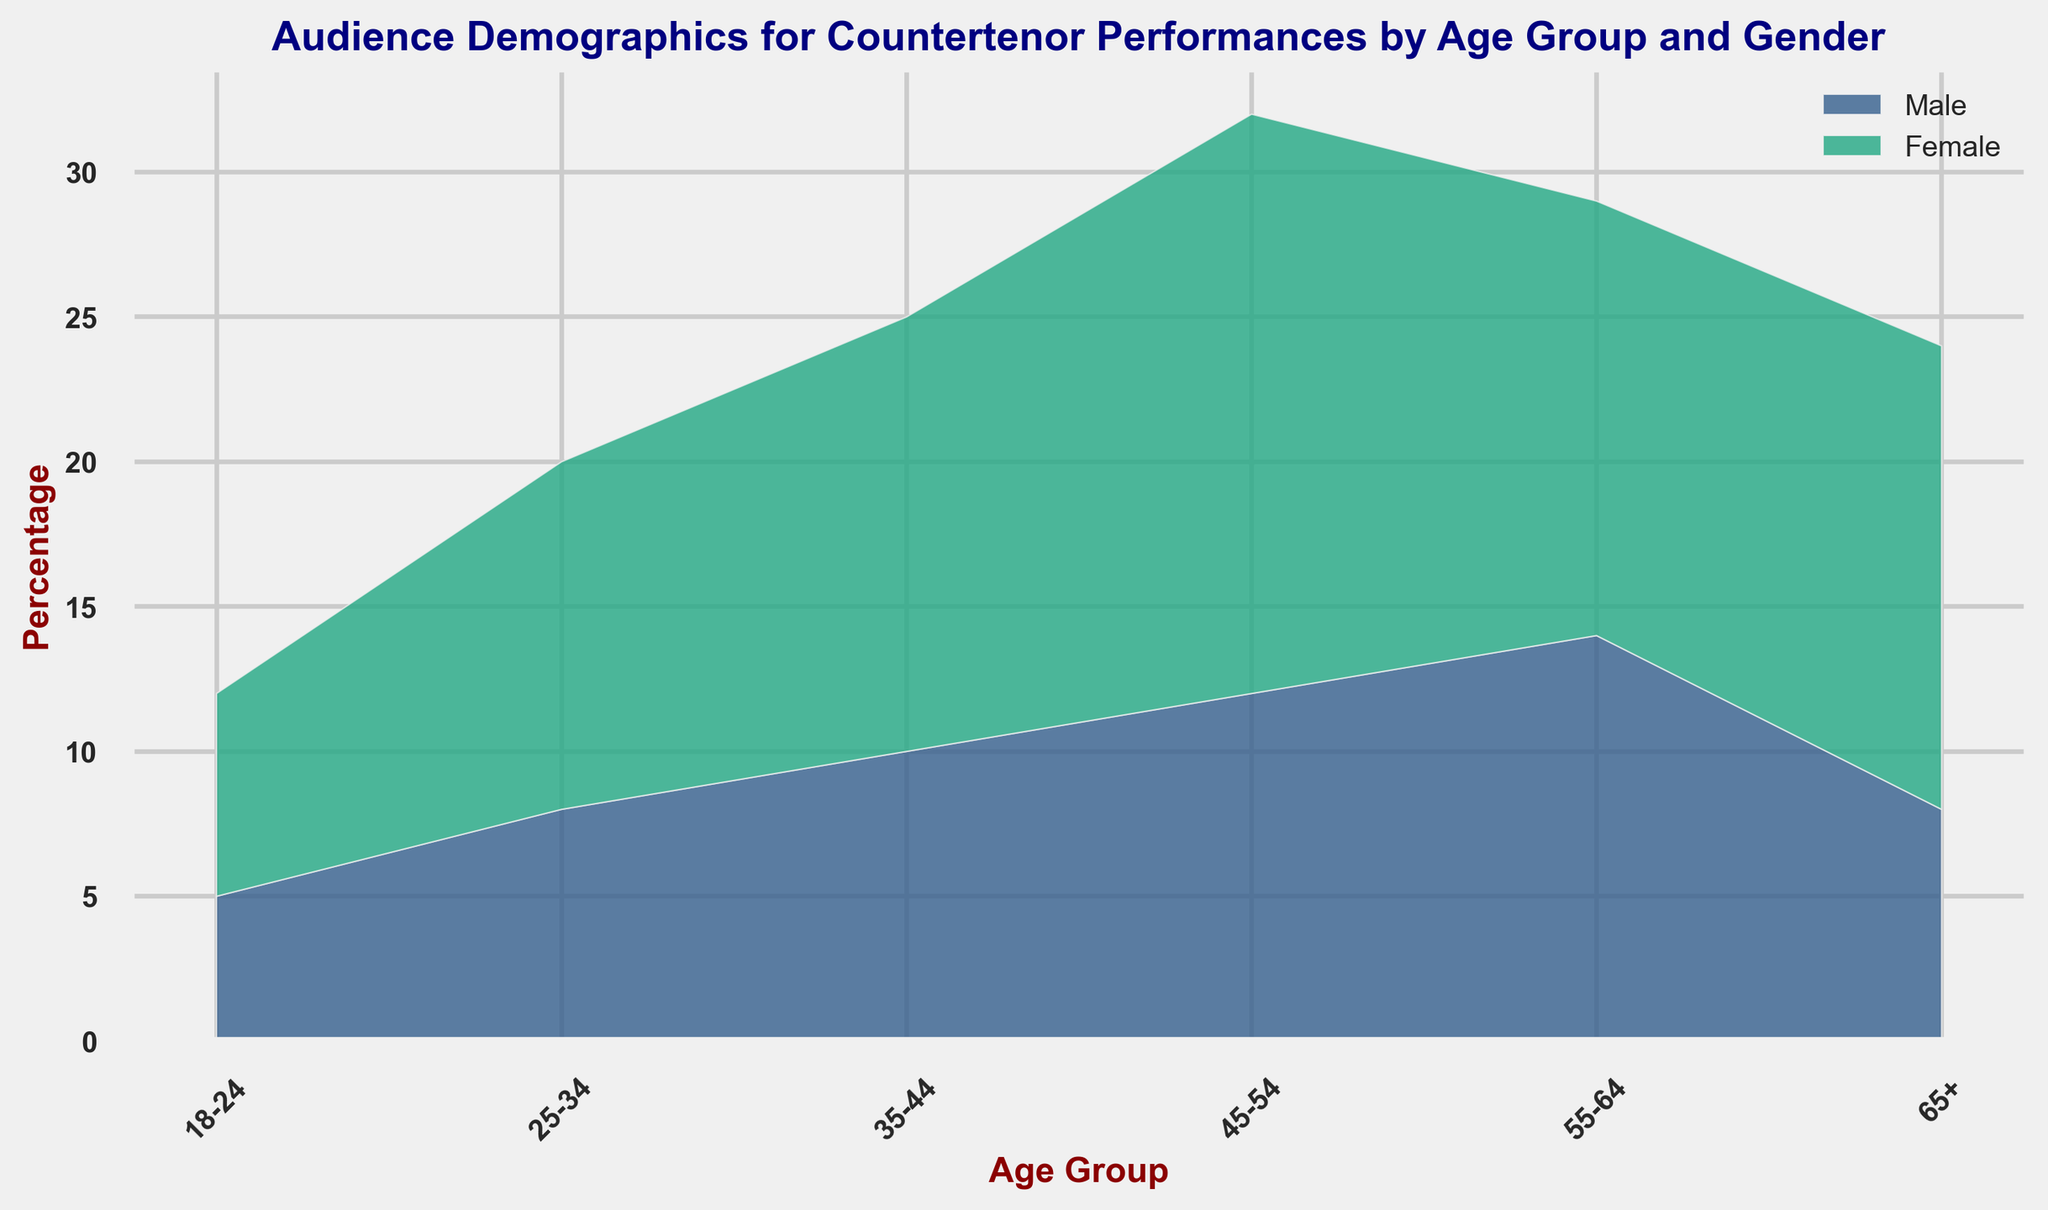What is the total percentage of female audiences across all age groups? First, identify the percentage values for females in each age group: 7 (18-24), 12 (25-34), 15 (35-44), 20 (45-54), 15 (55-64), and 16 (65+). Sum these values: 7 + 12 + 15 + 20 + 15 + 16 = 85
Answer: 85 Which age group has the highest percentage of male audiences? Identify the male percentages for each age group: 5 (18-24), 8 (25-34), 10 (35-44), 12 (45-54), 14 (55-64), and 8 (65+). The highest value is 14 in the 55-64 age group
Answer: 55-64 How does the percentage of female audiences in the 45-54 age group compare to the male audiences in the same age group? The percentage for females in the 45-54 age group is 20, and for males is 12. Compare these two values: 20 is greater than 12
Answer: Female percentage is higher What is the difference in the total percentage of audiences between the youngest (18-24) and oldest (65+) age groups? Calculate total percentages for each age group: 18-24 years (5 + 7 = 12), and 65+ years (8 + 16 = 24). The difference is 24 - 12
Answer: 12 Among the 35-44 age group, which gender has a higher audience percentage and by how much? The percentage for males is 10, and for females is 15. Calculate the difference: 15 - 10 = 5
Answer: Female by 5 What is the average percentage of audiences in the 25-34 age group? Add male (8) and female (12) percentages, then divide by 2: (8 + 12) / 2 = 10
Answer: 10 Which age group has the smallest total audience percentage, and what is that percentage? Calculate the total for each age group: 18-24 (5+7=12), 25-34 (8+12=20), 35-44 (10+15=25), 45-54 (12+20=32), 55-64 (14+15=29), 65+ (8+16=24). The smallest is 12 in the 18-24 age group
Answer: 18-24 with 12 In the 55-64 age group, do males or females have a greater audience percentage, and by what factor? Percentages are 14 for males and 15 for females. The factor by which females exceed males is 15 / 14 ≈ 1.07
Answer: Females by about 1.07 Which gender has a higher total percentage across all age groups? Calculate the total for males: 5+8+10+12+14+8=57, and for females: 7+12+15+20+15+16=85. Compare these totals
Answer: Females Is the audience more balanced in terms of gender for the 18-24 age group or the 35-44 age group? Compare the male to female percentages for each age group: 18-24 (5 males vs 7 females), 35-44 (10 males vs 15 females). The smaller difference indicates a more balanced group. Differences are: 7-5=2 for 18-24 and 15-10=5 for 35-44
Answer: 18-24 